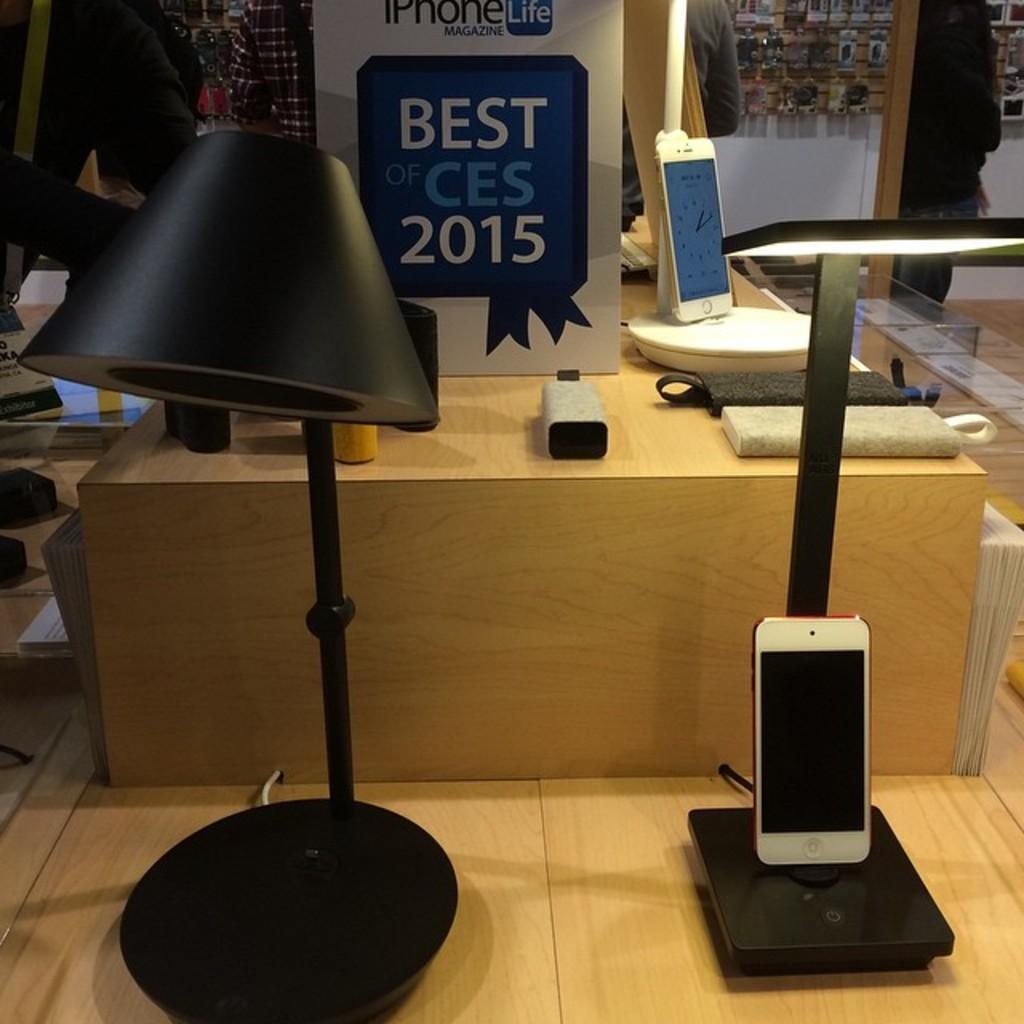What can be seen on stands in the image? There are mobiles on stands in the image. What is located on a platform in the image? There are objects on a platform in the image. Who or what is present in the image? There are people in the image. What is the source of illumination in the image? There is light visible in the image. What type of signage is present in the image? There is a hoarding in the image. What is hanging on a board on the wall in the background? In the background, objects are hanging on a board on the wall. Where is the throne located in the image? There is no throne present in the image. What type of stitch is being used by the people in the image? There is no stitching activity depicted in the image. 